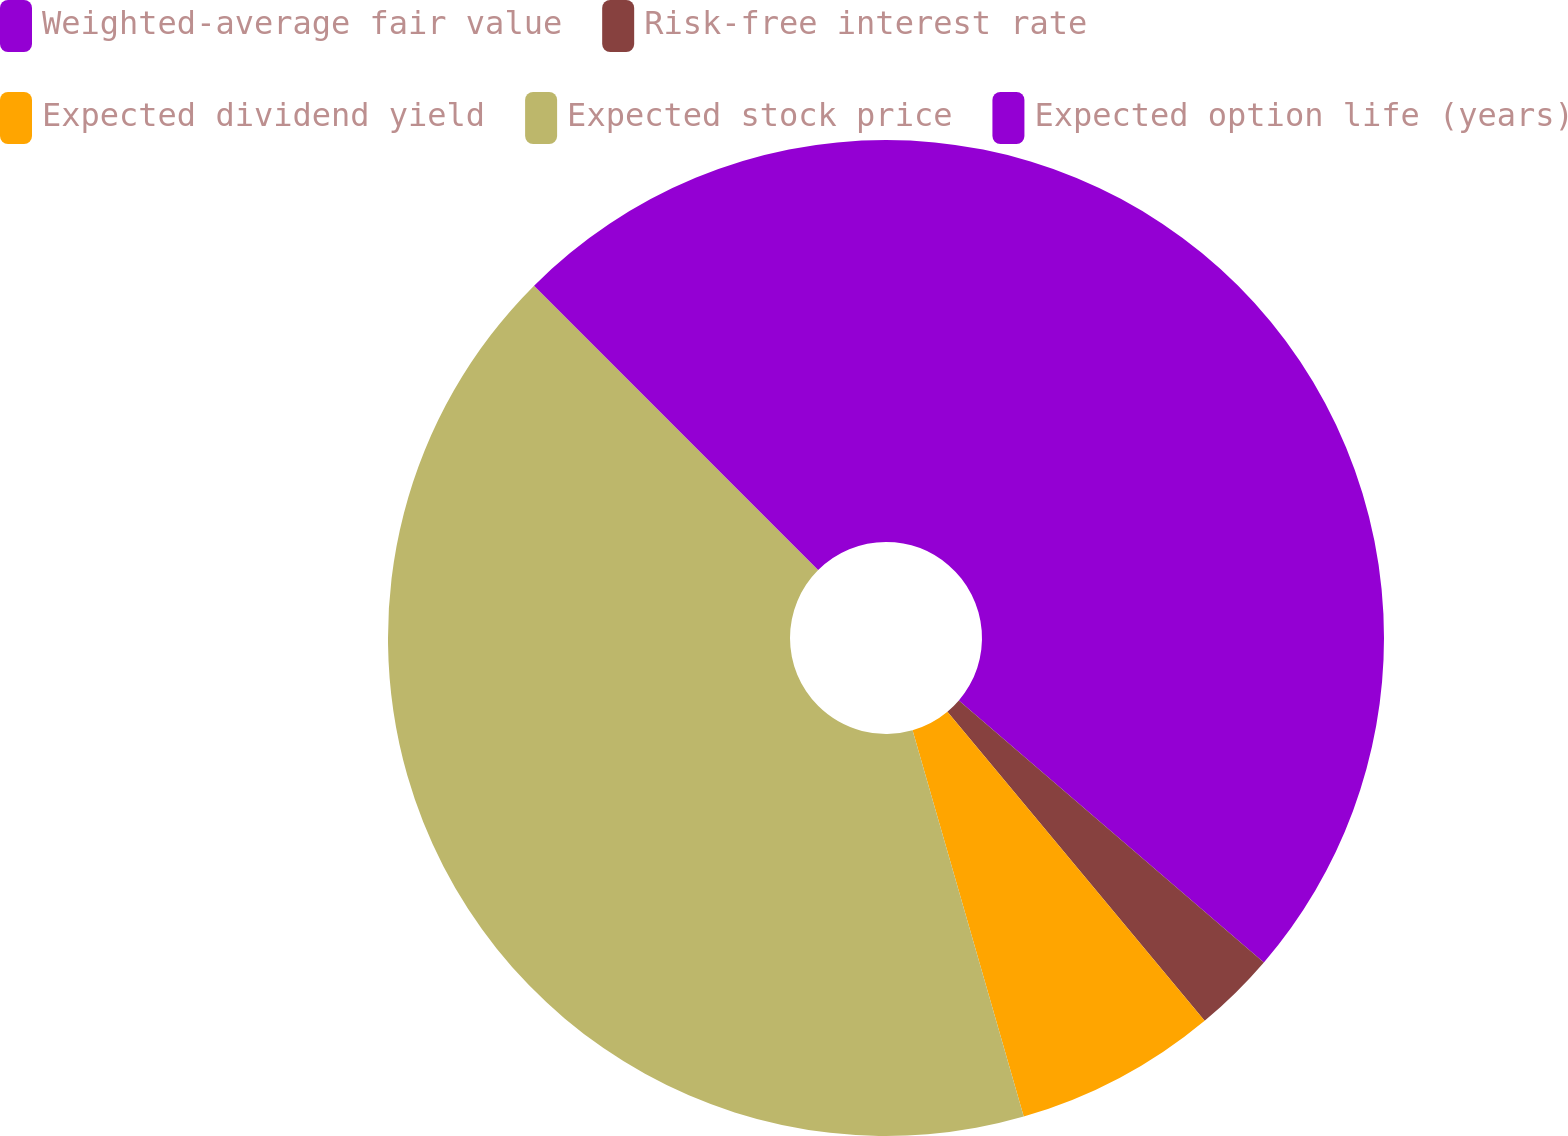Convert chart to OTSL. <chart><loc_0><loc_0><loc_500><loc_500><pie_chart><fcel>Weighted-average fair value<fcel>Risk-free interest rate<fcel>Expected dividend yield<fcel>Expected stock price<fcel>Expected option life (years)<nl><fcel>36.29%<fcel>2.66%<fcel>6.59%<fcel>41.97%<fcel>12.49%<nl></chart> 